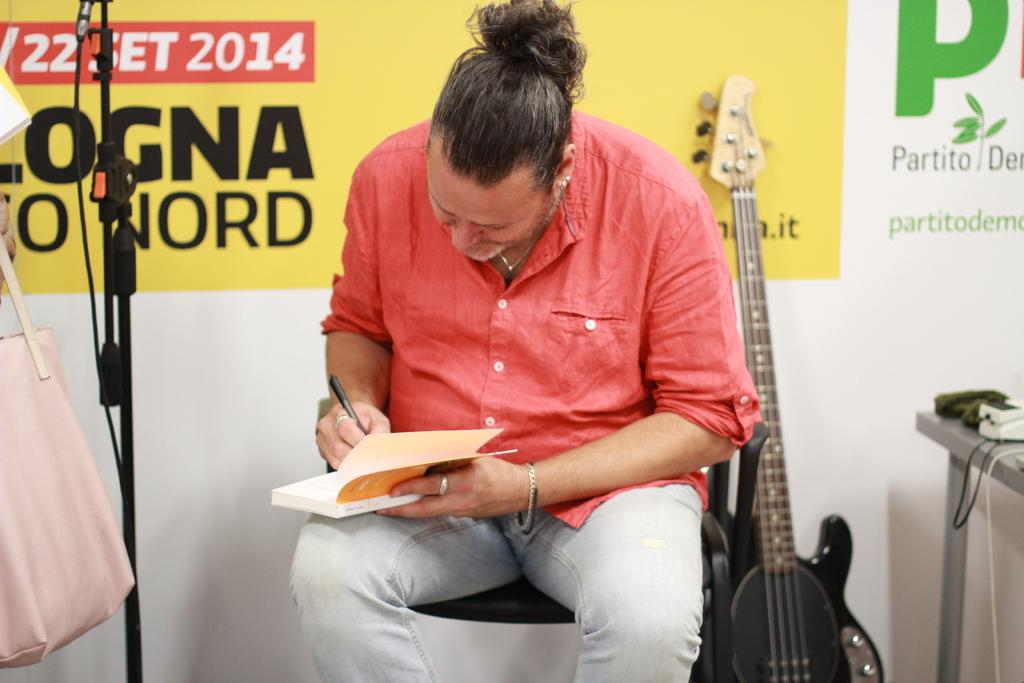<image>
Share a concise interpretation of the image provided. A man is signing a book in 2014 next to a guitar. 